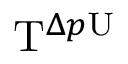<formula> <loc_0><loc_0><loc_500><loc_500>T ^ { \Delta p U }</formula> 